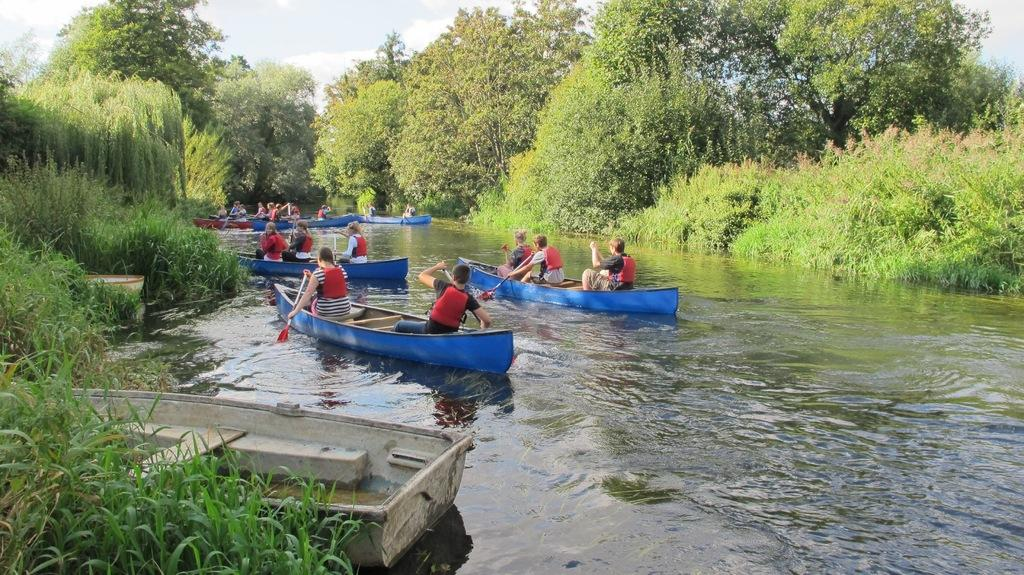What are the people in the image doing? The people in the image are rowing boats. Where are the boats located? The boats are on the water. What can be seen in the background of the image? There are plants, trees, and the sky visible in the background of the image. What type of juice is being served during the winter season in the image? There is no reference to a meeting, juice, or winter season in the image, so it's not possible to determine what, if any, juice might be served. 